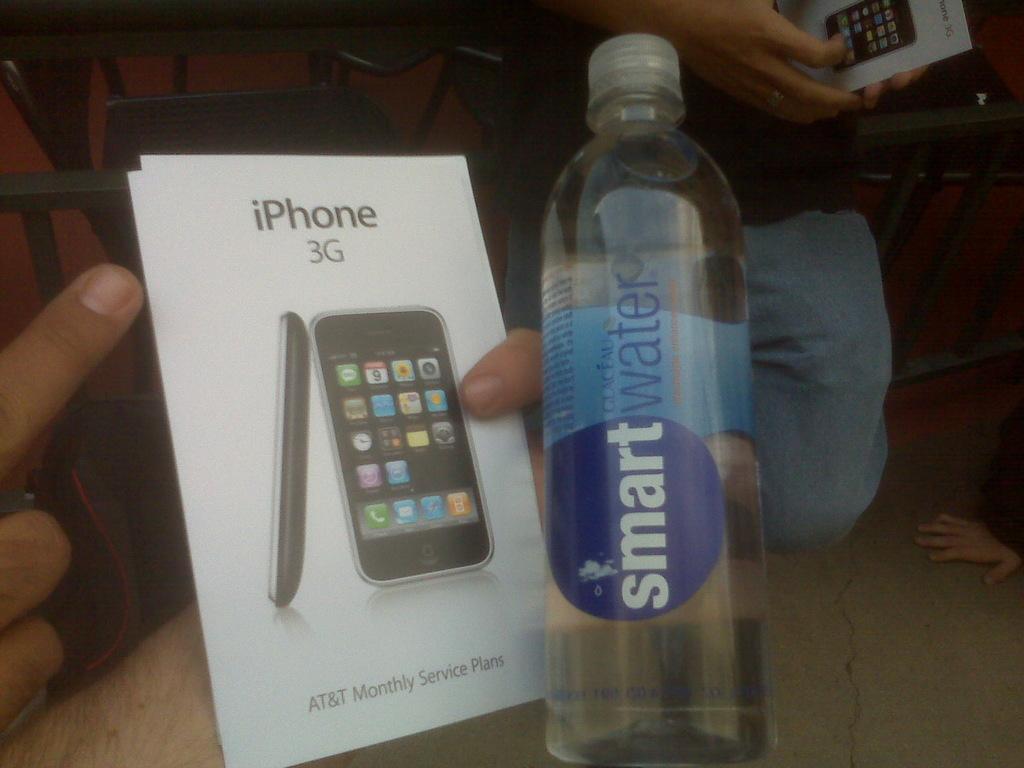What brand is the bottled water?
Provide a succinct answer. Smart water. 